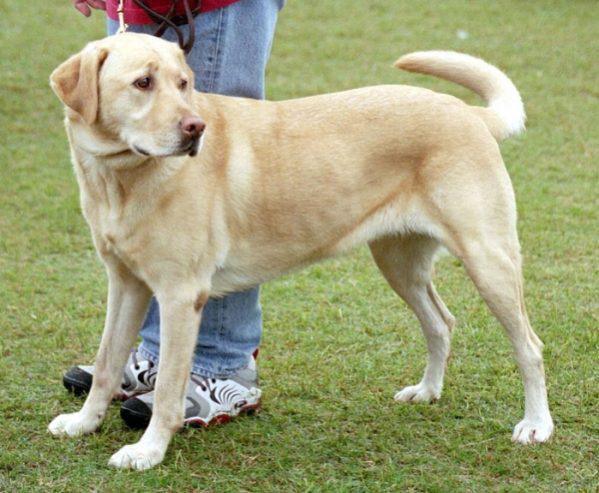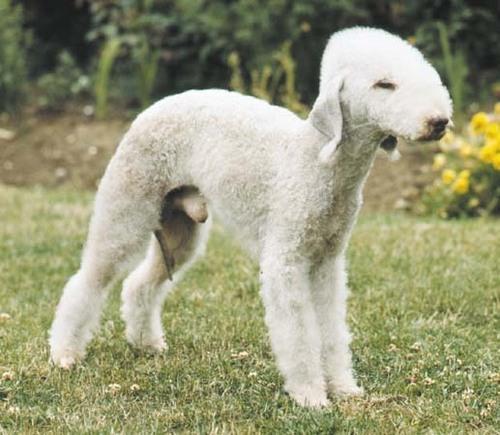The first image is the image on the left, the second image is the image on the right. Evaluate the accuracy of this statement regarding the images: "An image shows a standing dog with an open mouth and a collar around its neck.". Is it true? Answer yes or no. No. The first image is the image on the left, the second image is the image on the right. Considering the images on both sides, is "One of the dogs is lying down and looking at the camera." valid? Answer yes or no. No. 